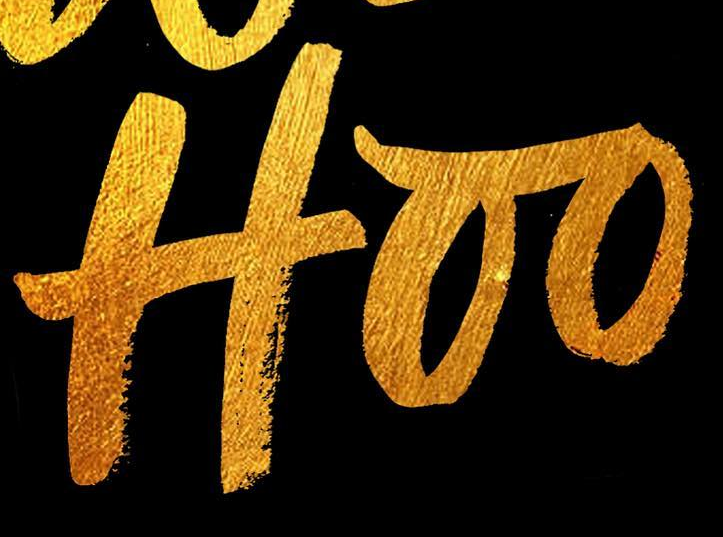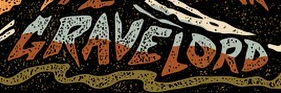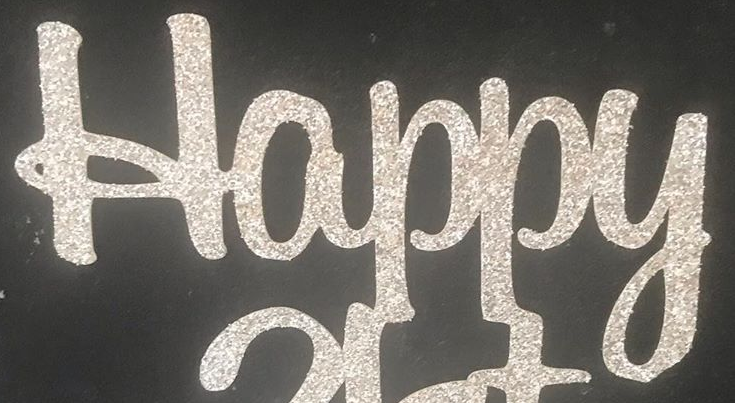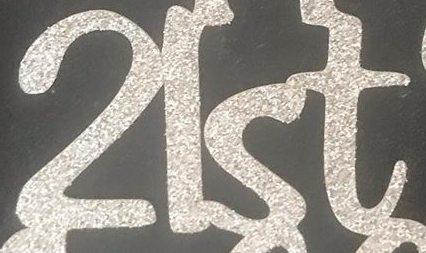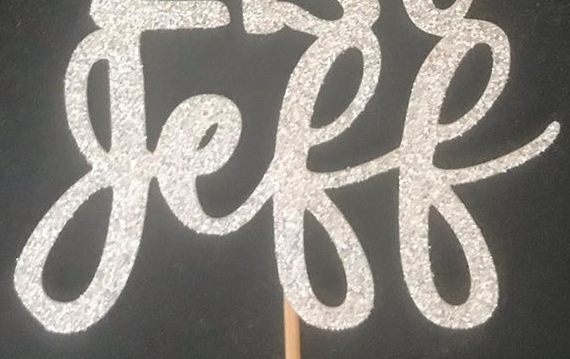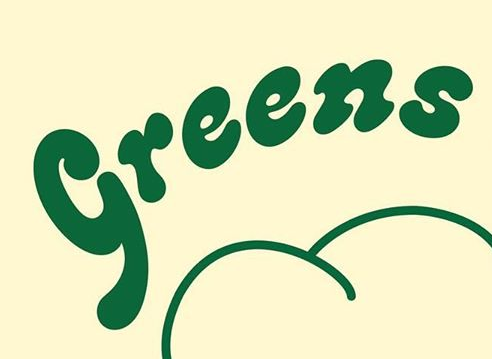Read the text content from these images in order, separated by a semicolon. Hoo; GRAVELORD; Happy; 2lst; geff; Greens 